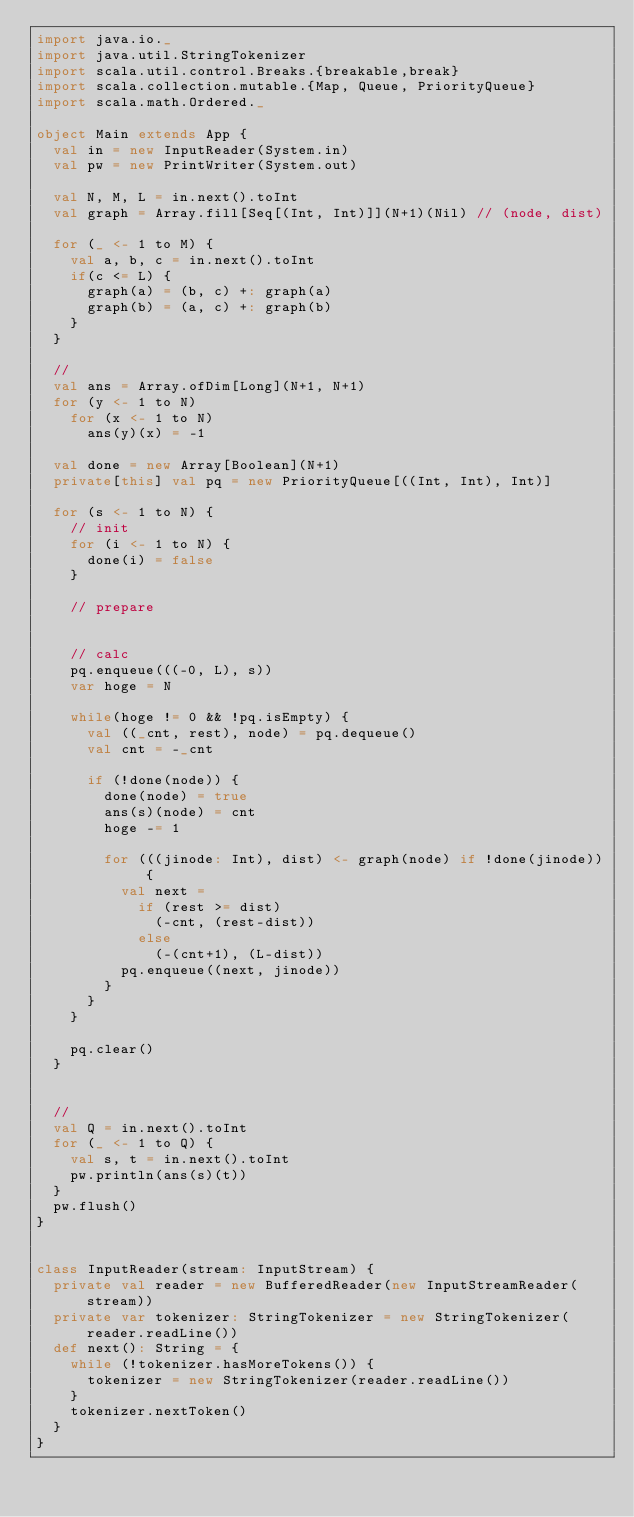Convert code to text. <code><loc_0><loc_0><loc_500><loc_500><_Scala_>import java.io._
import java.util.StringTokenizer
import scala.util.control.Breaks.{breakable,break}
import scala.collection.mutable.{Map, Queue, PriorityQueue}
import scala.math.Ordered._

object Main extends App {
  val in = new InputReader(System.in)
  val pw = new PrintWriter(System.out)

  val N, M, L = in.next().toInt
  val graph = Array.fill[Seq[(Int, Int)]](N+1)(Nil) // (node, dist)

  for (_ <- 1 to M) {
    val a, b, c = in.next().toInt
    if(c <= L) {
      graph(a) = (b, c) +: graph(a)
      graph(b) = (a, c) +: graph(b)
    }
  }

  // 
  val ans = Array.ofDim[Long](N+1, N+1)
  for (y <- 1 to N)
    for (x <- 1 to N)
      ans(y)(x) = -1

  val done = new Array[Boolean](N+1)
  private[this] val pq = new PriorityQueue[((Int, Int), Int)]

  for (s <- 1 to N) {
    // init
    for (i <- 1 to N) {
      done(i) = false
    }

    // prepare


    // calc
    pq.enqueue(((-0, L), s))
    var hoge = N

    while(hoge != 0 && !pq.isEmpty) {
      val ((_cnt, rest), node) = pq.dequeue()
      val cnt = -_cnt

      if (!done(node)) {
        done(node) = true
        ans(s)(node) = cnt
        hoge -= 1

        for (((jinode: Int), dist) <- graph(node) if !done(jinode)) {
          val next =
            if (rest >= dist)
              (-cnt, (rest-dist))
            else
              (-(cnt+1), (L-dist))
          pq.enqueue((next, jinode))
        }
      }
    }

    pq.clear()
  }

  
  //
  val Q = in.next().toInt
  for (_ <- 1 to Q) {
    val s, t = in.next().toInt
    pw.println(ans(s)(t))
  }
  pw.flush()
}


class InputReader(stream: InputStream) {
  private val reader = new BufferedReader(new InputStreamReader(stream))
  private var tokenizer: StringTokenizer = new StringTokenizer(reader.readLine())
  def next(): String = {
    while (!tokenizer.hasMoreTokens()) {
      tokenizer = new StringTokenizer(reader.readLine())
    }
    tokenizer.nextToken()
  }
}
</code> 